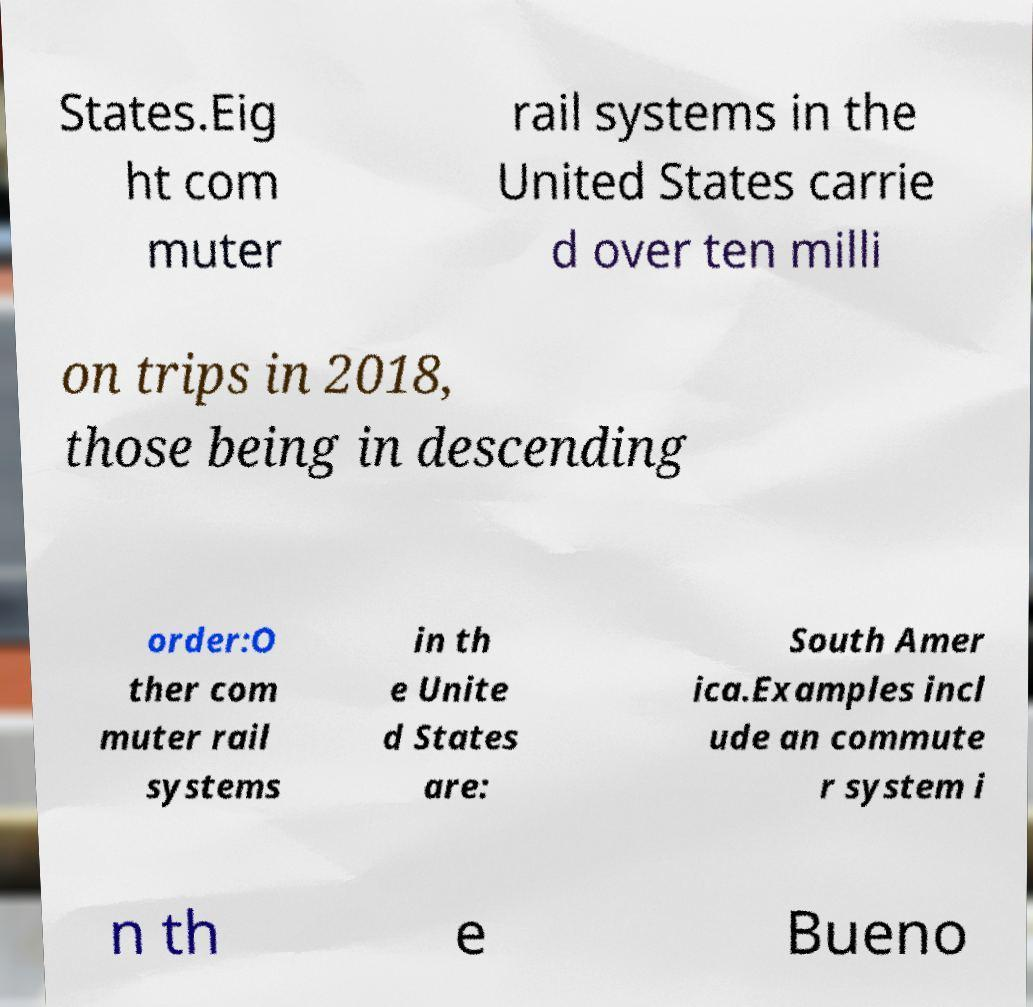Please identify and transcribe the text found in this image. States.Eig ht com muter rail systems in the United States carrie d over ten milli on trips in 2018, those being in descending order:O ther com muter rail systems in th e Unite d States are: South Amer ica.Examples incl ude an commute r system i n th e Bueno 